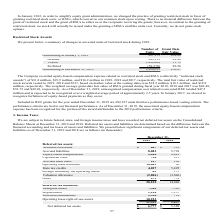According to Manhattan Associates's financial document, What is the outstanding number of units at the beginning of 2019? According to the financial document, 997,173. The relevant text states: "Outstanding at January 1, 2019 997,173 $52.22..." Also, What the number of forfeited shares in 2019? According to the financial document, 59,579. The relevant text states: "Forfeited (59,579) 50.56..." Also, What is the outstanding number of shares at the end of 2019? According to the financial document, 1,496,693. The relevant text states: "Outstanding at December 31, 2019 1,496,693 $50.67..." Also, can you calculate: What is the value difference between granted share and vested share? Based on the calculation: 51.79-49.48, the result is 2.31. This is based on the information: "Vested (386,060) 51.79 Granted 945,159 49.48..." The key data points involved are: 49.48, 51.79. Also, can you calculate: What is the change in the outstanding number of shares between the beginning and end of the year 2019? Based on the calculation: 1,496,693-997,173, the result is 499520. This is based on the information: "Outstanding at December 31, 2019 1,496,693 $50.67 Outstanding at January 1, 2019 997,173 $52.22..." The key data points involved are: 1,496,693, 997,173. Also, can you calculate: What is the difference in grant date fair value between the vested stocks and the forfeited stocks? Based on the calculation: 51.79-50.56, the result is 1.23. This is based on the information: "Vested (386,060) 51.79 Forfeited (59,579) 50.56..." The key data points involved are: 50.56, 51.79. 